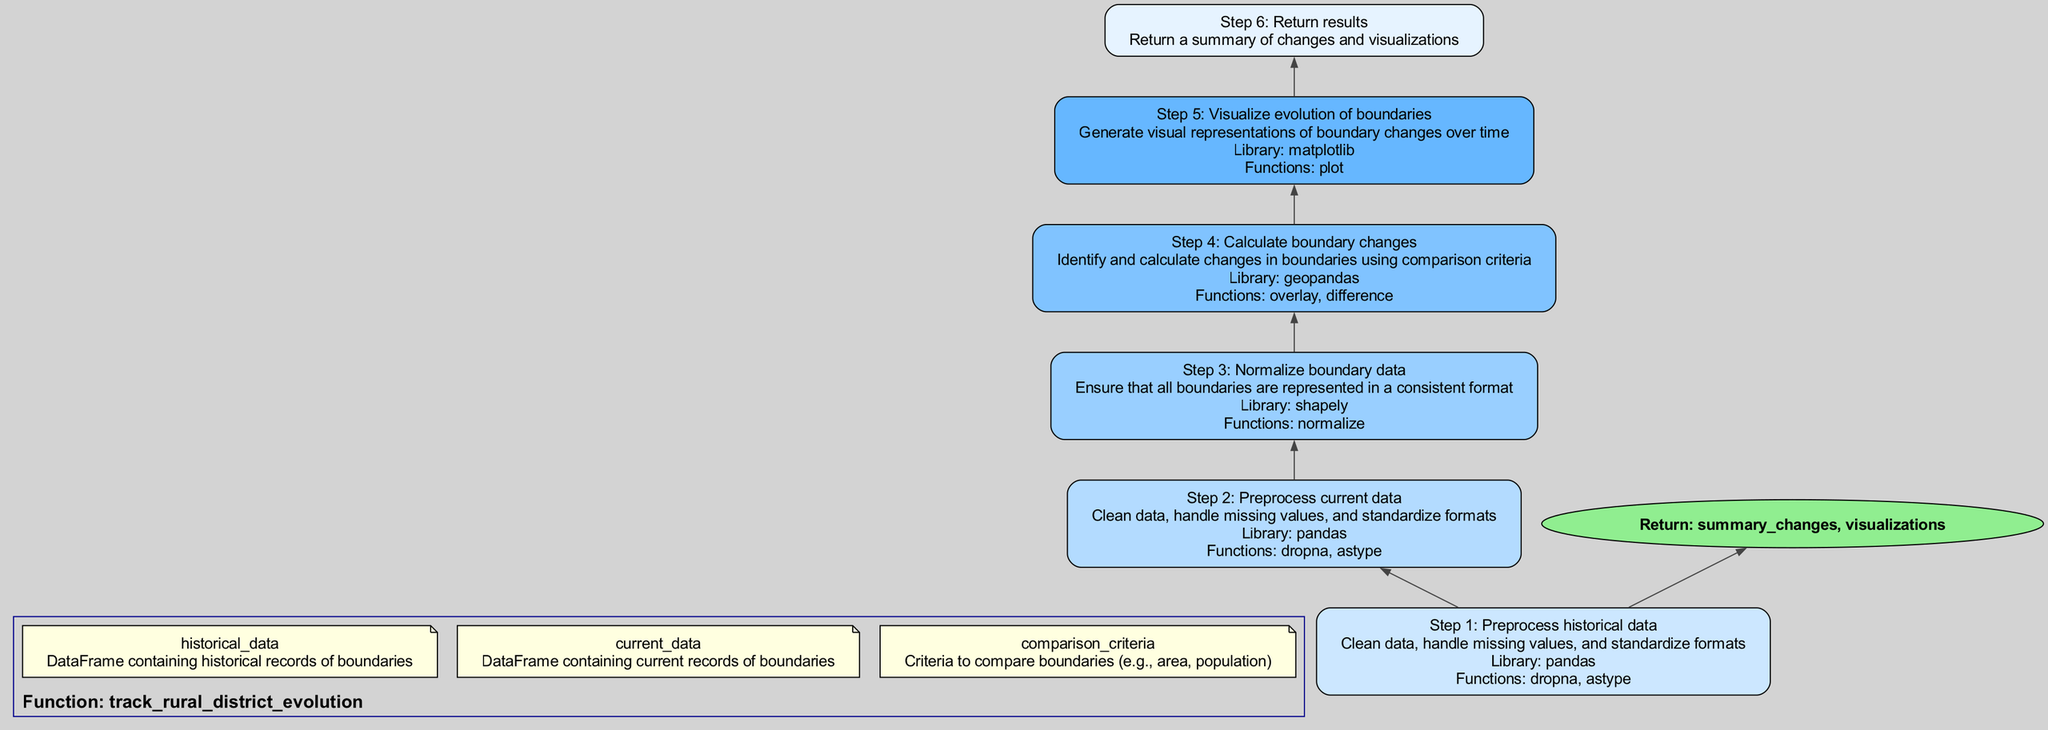What is the function name in the diagram? The function name is indicated at the top of the diagram in the cluster section. It states that the function being described is "track_rural_district_evolution".
Answer: track_rural_district_evolution How many steps are in the function body? Each step in the function body is labeled numerically from step 1 to step 6, which totals six steps.
Answer: 6 What is the library used in step 4? The library mentioned in step 4 is listed within the details of that step. It states that "geopandas" is used to calculate boundary changes.
Answer: geopandas What action is taken in step 3? The action in step 3 is clearly stated in the diagram as "Normalize boundary data". This is what is highlighted in that particular node of the flowchart.
Answer: Normalize boundary data What does the diagram return at the end? The end of the flowchart specifies that the return statement provides "summary_changes, visualizations". This indicates what the function outputs.
Answer: summary_changes, visualizations Which step involves visualizing the evolution of boundaries? Step 5 of the flowchart is focused on this action and is titled "Visualize evolution of boundaries", which describes the relevant process.
Answer: Step 5 What action is repeated in both step 1 and step 2? Both steps involve the action of preprocessing data, specifically cleaning data and handling missing values as mentioned in their respective details.
Answer: Preprocess data In which step is the "normalize" function used? The usage of the "normalize" function is specifically noted in step 3, where boundary data is normalized.
Answer: Step 3 What are the elements returned by the function? The final node in the diagram details the elements returned by the function, which are "summary_changes" and "visualizations".
Answer: summary_changes, visualizations 